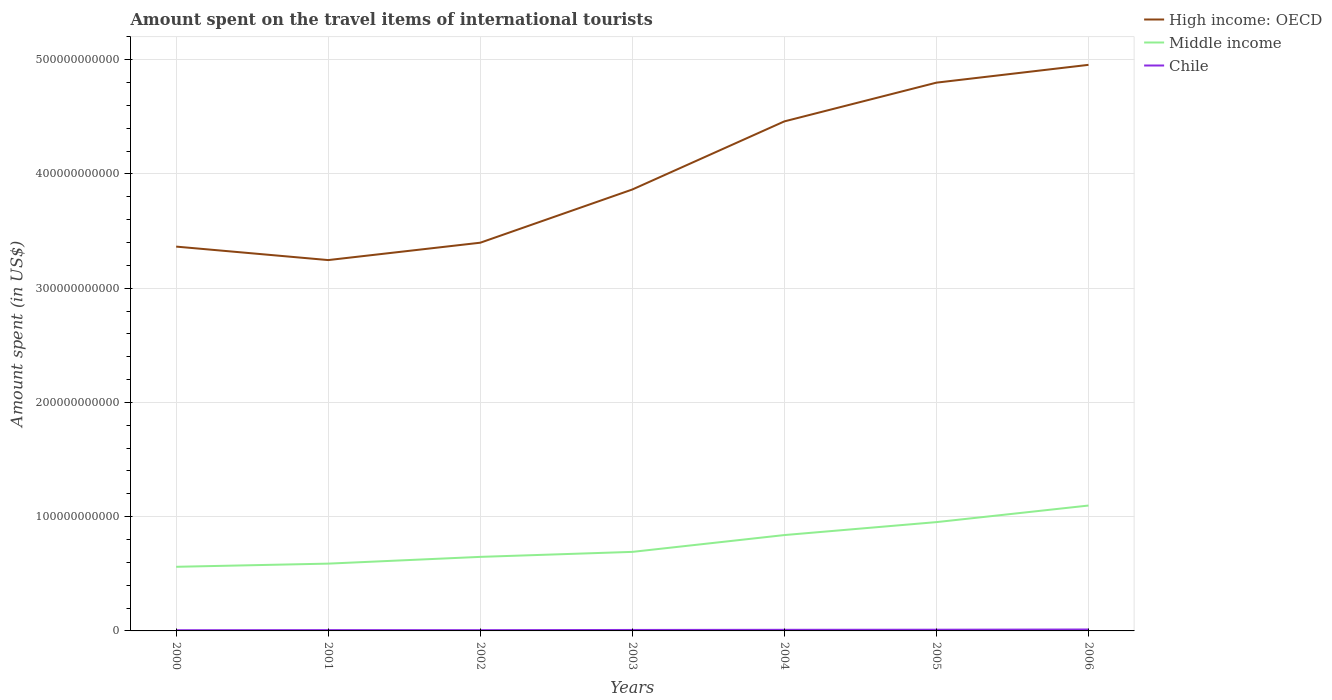Is the number of lines equal to the number of legend labels?
Ensure brevity in your answer.  Yes. Across all years, what is the maximum amount spent on the travel items of international tourists in Chile?
Ensure brevity in your answer.  6.20e+08. In which year was the amount spent on the travel items of international tourists in Middle income maximum?
Offer a very short reply. 2000. What is the total amount spent on the travel items of international tourists in Middle income in the graph?
Offer a terse response. -1.45e+1. What is the difference between the highest and the second highest amount spent on the travel items of international tourists in Middle income?
Your answer should be very brief. 5.36e+1. Is the amount spent on the travel items of international tourists in Chile strictly greater than the amount spent on the travel items of international tourists in Middle income over the years?
Offer a very short reply. Yes. What is the difference between two consecutive major ticks on the Y-axis?
Your answer should be very brief. 1.00e+11. Does the graph contain any zero values?
Offer a very short reply. No. How many legend labels are there?
Offer a very short reply. 3. How are the legend labels stacked?
Your answer should be very brief. Vertical. What is the title of the graph?
Your response must be concise. Amount spent on the travel items of international tourists. Does "Armenia" appear as one of the legend labels in the graph?
Your response must be concise. No. What is the label or title of the X-axis?
Offer a very short reply. Years. What is the label or title of the Y-axis?
Keep it short and to the point. Amount spent (in US$). What is the Amount spent (in US$) in High income: OECD in 2000?
Ensure brevity in your answer.  3.36e+11. What is the Amount spent (in US$) in Middle income in 2000?
Your answer should be very brief. 5.61e+1. What is the Amount spent (in US$) of Chile in 2000?
Offer a terse response. 6.20e+08. What is the Amount spent (in US$) of High income: OECD in 2001?
Your answer should be compact. 3.25e+11. What is the Amount spent (in US$) in Middle income in 2001?
Your answer should be compact. 5.89e+1. What is the Amount spent (in US$) in Chile in 2001?
Make the answer very short. 7.08e+08. What is the Amount spent (in US$) in High income: OECD in 2002?
Offer a very short reply. 3.40e+11. What is the Amount spent (in US$) of Middle income in 2002?
Offer a terse response. 6.48e+1. What is the Amount spent (in US$) of Chile in 2002?
Offer a terse response. 6.73e+08. What is the Amount spent (in US$) in High income: OECD in 2003?
Your answer should be compact. 3.86e+11. What is the Amount spent (in US$) of Middle income in 2003?
Ensure brevity in your answer.  6.92e+1. What is the Amount spent (in US$) of Chile in 2003?
Ensure brevity in your answer.  8.50e+08. What is the Amount spent (in US$) in High income: OECD in 2004?
Provide a succinct answer. 4.46e+11. What is the Amount spent (in US$) in Middle income in 2004?
Your answer should be compact. 8.39e+1. What is the Amount spent (in US$) in Chile in 2004?
Make the answer very short. 9.77e+08. What is the Amount spent (in US$) in High income: OECD in 2005?
Give a very brief answer. 4.80e+11. What is the Amount spent (in US$) in Middle income in 2005?
Provide a succinct answer. 9.52e+1. What is the Amount spent (in US$) of Chile in 2005?
Your answer should be very brief. 1.05e+09. What is the Amount spent (in US$) in High income: OECD in 2006?
Your response must be concise. 4.95e+11. What is the Amount spent (in US$) in Middle income in 2006?
Your response must be concise. 1.10e+11. What is the Amount spent (in US$) of Chile in 2006?
Keep it short and to the point. 1.24e+09. Across all years, what is the maximum Amount spent (in US$) in High income: OECD?
Keep it short and to the point. 4.95e+11. Across all years, what is the maximum Amount spent (in US$) in Middle income?
Offer a terse response. 1.10e+11. Across all years, what is the maximum Amount spent (in US$) of Chile?
Provide a short and direct response. 1.24e+09. Across all years, what is the minimum Amount spent (in US$) in High income: OECD?
Your answer should be very brief. 3.25e+11. Across all years, what is the minimum Amount spent (in US$) of Middle income?
Keep it short and to the point. 5.61e+1. Across all years, what is the minimum Amount spent (in US$) in Chile?
Give a very brief answer. 6.20e+08. What is the total Amount spent (in US$) of High income: OECD in the graph?
Provide a succinct answer. 2.81e+12. What is the total Amount spent (in US$) of Middle income in the graph?
Offer a very short reply. 5.38e+11. What is the total Amount spent (in US$) of Chile in the graph?
Provide a short and direct response. 6.12e+09. What is the difference between the Amount spent (in US$) of High income: OECD in 2000 and that in 2001?
Your answer should be compact. 1.18e+1. What is the difference between the Amount spent (in US$) of Middle income in 2000 and that in 2001?
Ensure brevity in your answer.  -2.77e+09. What is the difference between the Amount spent (in US$) of Chile in 2000 and that in 2001?
Provide a succinct answer. -8.80e+07. What is the difference between the Amount spent (in US$) in High income: OECD in 2000 and that in 2002?
Offer a terse response. -3.41e+09. What is the difference between the Amount spent (in US$) in Middle income in 2000 and that in 2002?
Give a very brief answer. -8.68e+09. What is the difference between the Amount spent (in US$) of Chile in 2000 and that in 2002?
Your answer should be compact. -5.30e+07. What is the difference between the Amount spent (in US$) of High income: OECD in 2000 and that in 2003?
Keep it short and to the point. -5.00e+1. What is the difference between the Amount spent (in US$) of Middle income in 2000 and that in 2003?
Your response must be concise. -1.31e+1. What is the difference between the Amount spent (in US$) of Chile in 2000 and that in 2003?
Your answer should be very brief. -2.30e+08. What is the difference between the Amount spent (in US$) of High income: OECD in 2000 and that in 2004?
Give a very brief answer. -1.10e+11. What is the difference between the Amount spent (in US$) of Middle income in 2000 and that in 2004?
Make the answer very short. -2.78e+1. What is the difference between the Amount spent (in US$) of Chile in 2000 and that in 2004?
Your answer should be compact. -3.57e+08. What is the difference between the Amount spent (in US$) in High income: OECD in 2000 and that in 2005?
Offer a terse response. -1.44e+11. What is the difference between the Amount spent (in US$) of Middle income in 2000 and that in 2005?
Keep it short and to the point. -3.91e+1. What is the difference between the Amount spent (in US$) of Chile in 2000 and that in 2005?
Offer a terse response. -4.31e+08. What is the difference between the Amount spent (in US$) in High income: OECD in 2000 and that in 2006?
Your response must be concise. -1.59e+11. What is the difference between the Amount spent (in US$) in Middle income in 2000 and that in 2006?
Your response must be concise. -5.36e+1. What is the difference between the Amount spent (in US$) in Chile in 2000 and that in 2006?
Offer a terse response. -6.19e+08. What is the difference between the Amount spent (in US$) in High income: OECD in 2001 and that in 2002?
Offer a terse response. -1.52e+1. What is the difference between the Amount spent (in US$) in Middle income in 2001 and that in 2002?
Provide a short and direct response. -5.91e+09. What is the difference between the Amount spent (in US$) of Chile in 2001 and that in 2002?
Your answer should be compact. 3.50e+07. What is the difference between the Amount spent (in US$) in High income: OECD in 2001 and that in 2003?
Offer a very short reply. -6.18e+1. What is the difference between the Amount spent (in US$) in Middle income in 2001 and that in 2003?
Your answer should be very brief. -1.03e+1. What is the difference between the Amount spent (in US$) in Chile in 2001 and that in 2003?
Offer a very short reply. -1.42e+08. What is the difference between the Amount spent (in US$) in High income: OECD in 2001 and that in 2004?
Offer a terse response. -1.21e+11. What is the difference between the Amount spent (in US$) of Middle income in 2001 and that in 2004?
Ensure brevity in your answer.  -2.50e+1. What is the difference between the Amount spent (in US$) of Chile in 2001 and that in 2004?
Keep it short and to the point. -2.69e+08. What is the difference between the Amount spent (in US$) in High income: OECD in 2001 and that in 2005?
Your response must be concise. -1.55e+11. What is the difference between the Amount spent (in US$) of Middle income in 2001 and that in 2005?
Your answer should be very brief. -3.63e+1. What is the difference between the Amount spent (in US$) in Chile in 2001 and that in 2005?
Offer a terse response. -3.43e+08. What is the difference between the Amount spent (in US$) of High income: OECD in 2001 and that in 2006?
Your response must be concise. -1.71e+11. What is the difference between the Amount spent (in US$) in Middle income in 2001 and that in 2006?
Your answer should be very brief. -5.08e+1. What is the difference between the Amount spent (in US$) in Chile in 2001 and that in 2006?
Ensure brevity in your answer.  -5.31e+08. What is the difference between the Amount spent (in US$) in High income: OECD in 2002 and that in 2003?
Ensure brevity in your answer.  -4.66e+1. What is the difference between the Amount spent (in US$) of Middle income in 2002 and that in 2003?
Your answer should be very brief. -4.37e+09. What is the difference between the Amount spent (in US$) of Chile in 2002 and that in 2003?
Provide a succinct answer. -1.77e+08. What is the difference between the Amount spent (in US$) in High income: OECD in 2002 and that in 2004?
Provide a succinct answer. -1.06e+11. What is the difference between the Amount spent (in US$) of Middle income in 2002 and that in 2004?
Make the answer very short. -1.91e+1. What is the difference between the Amount spent (in US$) in Chile in 2002 and that in 2004?
Provide a succinct answer. -3.04e+08. What is the difference between the Amount spent (in US$) of High income: OECD in 2002 and that in 2005?
Offer a terse response. -1.40e+11. What is the difference between the Amount spent (in US$) of Middle income in 2002 and that in 2005?
Give a very brief answer. -3.04e+1. What is the difference between the Amount spent (in US$) of Chile in 2002 and that in 2005?
Ensure brevity in your answer.  -3.78e+08. What is the difference between the Amount spent (in US$) in High income: OECD in 2002 and that in 2006?
Your response must be concise. -1.56e+11. What is the difference between the Amount spent (in US$) of Middle income in 2002 and that in 2006?
Your answer should be very brief. -4.49e+1. What is the difference between the Amount spent (in US$) of Chile in 2002 and that in 2006?
Your response must be concise. -5.66e+08. What is the difference between the Amount spent (in US$) in High income: OECD in 2003 and that in 2004?
Keep it short and to the point. -5.96e+1. What is the difference between the Amount spent (in US$) in Middle income in 2003 and that in 2004?
Give a very brief answer. -1.47e+1. What is the difference between the Amount spent (in US$) of Chile in 2003 and that in 2004?
Your response must be concise. -1.27e+08. What is the difference between the Amount spent (in US$) in High income: OECD in 2003 and that in 2005?
Keep it short and to the point. -9.35e+1. What is the difference between the Amount spent (in US$) in Middle income in 2003 and that in 2005?
Offer a very short reply. -2.61e+1. What is the difference between the Amount spent (in US$) in Chile in 2003 and that in 2005?
Provide a succinct answer. -2.01e+08. What is the difference between the Amount spent (in US$) in High income: OECD in 2003 and that in 2006?
Your answer should be very brief. -1.09e+11. What is the difference between the Amount spent (in US$) of Middle income in 2003 and that in 2006?
Give a very brief answer. -4.06e+1. What is the difference between the Amount spent (in US$) in Chile in 2003 and that in 2006?
Keep it short and to the point. -3.89e+08. What is the difference between the Amount spent (in US$) of High income: OECD in 2004 and that in 2005?
Your answer should be very brief. -3.39e+1. What is the difference between the Amount spent (in US$) of Middle income in 2004 and that in 2005?
Ensure brevity in your answer.  -1.13e+1. What is the difference between the Amount spent (in US$) of Chile in 2004 and that in 2005?
Keep it short and to the point. -7.40e+07. What is the difference between the Amount spent (in US$) in High income: OECD in 2004 and that in 2006?
Give a very brief answer. -4.95e+1. What is the difference between the Amount spent (in US$) in Middle income in 2004 and that in 2006?
Your response must be concise. -2.58e+1. What is the difference between the Amount spent (in US$) in Chile in 2004 and that in 2006?
Keep it short and to the point. -2.62e+08. What is the difference between the Amount spent (in US$) of High income: OECD in 2005 and that in 2006?
Provide a short and direct response. -1.56e+1. What is the difference between the Amount spent (in US$) in Middle income in 2005 and that in 2006?
Your answer should be compact. -1.45e+1. What is the difference between the Amount spent (in US$) in Chile in 2005 and that in 2006?
Provide a succinct answer. -1.88e+08. What is the difference between the Amount spent (in US$) of High income: OECD in 2000 and the Amount spent (in US$) of Middle income in 2001?
Offer a very short reply. 2.77e+11. What is the difference between the Amount spent (in US$) in High income: OECD in 2000 and the Amount spent (in US$) in Chile in 2001?
Keep it short and to the point. 3.36e+11. What is the difference between the Amount spent (in US$) in Middle income in 2000 and the Amount spent (in US$) in Chile in 2001?
Make the answer very short. 5.54e+1. What is the difference between the Amount spent (in US$) in High income: OECD in 2000 and the Amount spent (in US$) in Middle income in 2002?
Your answer should be compact. 2.72e+11. What is the difference between the Amount spent (in US$) of High income: OECD in 2000 and the Amount spent (in US$) of Chile in 2002?
Offer a terse response. 3.36e+11. What is the difference between the Amount spent (in US$) in Middle income in 2000 and the Amount spent (in US$) in Chile in 2002?
Give a very brief answer. 5.55e+1. What is the difference between the Amount spent (in US$) of High income: OECD in 2000 and the Amount spent (in US$) of Middle income in 2003?
Your response must be concise. 2.67e+11. What is the difference between the Amount spent (in US$) of High income: OECD in 2000 and the Amount spent (in US$) of Chile in 2003?
Your response must be concise. 3.36e+11. What is the difference between the Amount spent (in US$) of Middle income in 2000 and the Amount spent (in US$) of Chile in 2003?
Make the answer very short. 5.53e+1. What is the difference between the Amount spent (in US$) in High income: OECD in 2000 and the Amount spent (in US$) in Middle income in 2004?
Provide a succinct answer. 2.52e+11. What is the difference between the Amount spent (in US$) of High income: OECD in 2000 and the Amount spent (in US$) of Chile in 2004?
Make the answer very short. 3.35e+11. What is the difference between the Amount spent (in US$) in Middle income in 2000 and the Amount spent (in US$) in Chile in 2004?
Keep it short and to the point. 5.52e+1. What is the difference between the Amount spent (in US$) in High income: OECD in 2000 and the Amount spent (in US$) in Middle income in 2005?
Your answer should be compact. 2.41e+11. What is the difference between the Amount spent (in US$) of High income: OECD in 2000 and the Amount spent (in US$) of Chile in 2005?
Your answer should be very brief. 3.35e+11. What is the difference between the Amount spent (in US$) in Middle income in 2000 and the Amount spent (in US$) in Chile in 2005?
Your answer should be very brief. 5.51e+1. What is the difference between the Amount spent (in US$) in High income: OECD in 2000 and the Amount spent (in US$) in Middle income in 2006?
Keep it short and to the point. 2.27e+11. What is the difference between the Amount spent (in US$) of High income: OECD in 2000 and the Amount spent (in US$) of Chile in 2006?
Offer a very short reply. 3.35e+11. What is the difference between the Amount spent (in US$) in Middle income in 2000 and the Amount spent (in US$) in Chile in 2006?
Give a very brief answer. 5.49e+1. What is the difference between the Amount spent (in US$) of High income: OECD in 2001 and the Amount spent (in US$) of Middle income in 2002?
Provide a succinct answer. 2.60e+11. What is the difference between the Amount spent (in US$) in High income: OECD in 2001 and the Amount spent (in US$) in Chile in 2002?
Make the answer very short. 3.24e+11. What is the difference between the Amount spent (in US$) in Middle income in 2001 and the Amount spent (in US$) in Chile in 2002?
Make the answer very short. 5.82e+1. What is the difference between the Amount spent (in US$) in High income: OECD in 2001 and the Amount spent (in US$) in Middle income in 2003?
Keep it short and to the point. 2.55e+11. What is the difference between the Amount spent (in US$) of High income: OECD in 2001 and the Amount spent (in US$) of Chile in 2003?
Ensure brevity in your answer.  3.24e+11. What is the difference between the Amount spent (in US$) in Middle income in 2001 and the Amount spent (in US$) in Chile in 2003?
Offer a terse response. 5.80e+1. What is the difference between the Amount spent (in US$) in High income: OECD in 2001 and the Amount spent (in US$) in Middle income in 2004?
Offer a terse response. 2.41e+11. What is the difference between the Amount spent (in US$) in High income: OECD in 2001 and the Amount spent (in US$) in Chile in 2004?
Keep it short and to the point. 3.24e+11. What is the difference between the Amount spent (in US$) of Middle income in 2001 and the Amount spent (in US$) of Chile in 2004?
Provide a succinct answer. 5.79e+1. What is the difference between the Amount spent (in US$) in High income: OECD in 2001 and the Amount spent (in US$) in Middle income in 2005?
Ensure brevity in your answer.  2.29e+11. What is the difference between the Amount spent (in US$) of High income: OECD in 2001 and the Amount spent (in US$) of Chile in 2005?
Ensure brevity in your answer.  3.24e+11. What is the difference between the Amount spent (in US$) of Middle income in 2001 and the Amount spent (in US$) of Chile in 2005?
Your answer should be compact. 5.78e+1. What is the difference between the Amount spent (in US$) of High income: OECD in 2001 and the Amount spent (in US$) of Middle income in 2006?
Your answer should be compact. 2.15e+11. What is the difference between the Amount spent (in US$) in High income: OECD in 2001 and the Amount spent (in US$) in Chile in 2006?
Your response must be concise. 3.23e+11. What is the difference between the Amount spent (in US$) in Middle income in 2001 and the Amount spent (in US$) in Chile in 2006?
Give a very brief answer. 5.77e+1. What is the difference between the Amount spent (in US$) in High income: OECD in 2002 and the Amount spent (in US$) in Middle income in 2003?
Your answer should be compact. 2.71e+11. What is the difference between the Amount spent (in US$) of High income: OECD in 2002 and the Amount spent (in US$) of Chile in 2003?
Your response must be concise. 3.39e+11. What is the difference between the Amount spent (in US$) in Middle income in 2002 and the Amount spent (in US$) in Chile in 2003?
Your answer should be very brief. 6.40e+1. What is the difference between the Amount spent (in US$) of High income: OECD in 2002 and the Amount spent (in US$) of Middle income in 2004?
Give a very brief answer. 2.56e+11. What is the difference between the Amount spent (in US$) in High income: OECD in 2002 and the Amount spent (in US$) in Chile in 2004?
Offer a very short reply. 3.39e+11. What is the difference between the Amount spent (in US$) of Middle income in 2002 and the Amount spent (in US$) of Chile in 2004?
Provide a succinct answer. 6.38e+1. What is the difference between the Amount spent (in US$) in High income: OECD in 2002 and the Amount spent (in US$) in Middle income in 2005?
Provide a succinct answer. 2.45e+11. What is the difference between the Amount spent (in US$) of High income: OECD in 2002 and the Amount spent (in US$) of Chile in 2005?
Keep it short and to the point. 3.39e+11. What is the difference between the Amount spent (in US$) of Middle income in 2002 and the Amount spent (in US$) of Chile in 2005?
Offer a very short reply. 6.38e+1. What is the difference between the Amount spent (in US$) of High income: OECD in 2002 and the Amount spent (in US$) of Middle income in 2006?
Your answer should be compact. 2.30e+11. What is the difference between the Amount spent (in US$) of High income: OECD in 2002 and the Amount spent (in US$) of Chile in 2006?
Provide a succinct answer. 3.39e+11. What is the difference between the Amount spent (in US$) in Middle income in 2002 and the Amount spent (in US$) in Chile in 2006?
Your response must be concise. 6.36e+1. What is the difference between the Amount spent (in US$) in High income: OECD in 2003 and the Amount spent (in US$) in Middle income in 2004?
Ensure brevity in your answer.  3.02e+11. What is the difference between the Amount spent (in US$) in High income: OECD in 2003 and the Amount spent (in US$) in Chile in 2004?
Give a very brief answer. 3.85e+11. What is the difference between the Amount spent (in US$) in Middle income in 2003 and the Amount spent (in US$) in Chile in 2004?
Your answer should be very brief. 6.82e+1. What is the difference between the Amount spent (in US$) in High income: OECD in 2003 and the Amount spent (in US$) in Middle income in 2005?
Provide a short and direct response. 2.91e+11. What is the difference between the Amount spent (in US$) in High income: OECD in 2003 and the Amount spent (in US$) in Chile in 2005?
Your answer should be compact. 3.85e+11. What is the difference between the Amount spent (in US$) of Middle income in 2003 and the Amount spent (in US$) of Chile in 2005?
Your response must be concise. 6.81e+1. What is the difference between the Amount spent (in US$) of High income: OECD in 2003 and the Amount spent (in US$) of Middle income in 2006?
Provide a short and direct response. 2.77e+11. What is the difference between the Amount spent (in US$) of High income: OECD in 2003 and the Amount spent (in US$) of Chile in 2006?
Provide a succinct answer. 3.85e+11. What is the difference between the Amount spent (in US$) of Middle income in 2003 and the Amount spent (in US$) of Chile in 2006?
Your answer should be compact. 6.79e+1. What is the difference between the Amount spent (in US$) of High income: OECD in 2004 and the Amount spent (in US$) of Middle income in 2005?
Provide a succinct answer. 3.51e+11. What is the difference between the Amount spent (in US$) of High income: OECD in 2004 and the Amount spent (in US$) of Chile in 2005?
Give a very brief answer. 4.45e+11. What is the difference between the Amount spent (in US$) in Middle income in 2004 and the Amount spent (in US$) in Chile in 2005?
Make the answer very short. 8.28e+1. What is the difference between the Amount spent (in US$) in High income: OECD in 2004 and the Amount spent (in US$) in Middle income in 2006?
Provide a succinct answer. 3.36e+11. What is the difference between the Amount spent (in US$) in High income: OECD in 2004 and the Amount spent (in US$) in Chile in 2006?
Ensure brevity in your answer.  4.45e+11. What is the difference between the Amount spent (in US$) in Middle income in 2004 and the Amount spent (in US$) in Chile in 2006?
Give a very brief answer. 8.27e+1. What is the difference between the Amount spent (in US$) of High income: OECD in 2005 and the Amount spent (in US$) of Middle income in 2006?
Your answer should be compact. 3.70e+11. What is the difference between the Amount spent (in US$) of High income: OECD in 2005 and the Amount spent (in US$) of Chile in 2006?
Provide a succinct answer. 4.79e+11. What is the difference between the Amount spent (in US$) of Middle income in 2005 and the Amount spent (in US$) of Chile in 2006?
Keep it short and to the point. 9.40e+1. What is the average Amount spent (in US$) in High income: OECD per year?
Offer a very short reply. 4.01e+11. What is the average Amount spent (in US$) in Middle income per year?
Your answer should be very brief. 7.68e+1. What is the average Amount spent (in US$) of Chile per year?
Your answer should be compact. 8.74e+08. In the year 2000, what is the difference between the Amount spent (in US$) in High income: OECD and Amount spent (in US$) in Middle income?
Your answer should be compact. 2.80e+11. In the year 2000, what is the difference between the Amount spent (in US$) of High income: OECD and Amount spent (in US$) of Chile?
Provide a short and direct response. 3.36e+11. In the year 2000, what is the difference between the Amount spent (in US$) in Middle income and Amount spent (in US$) in Chile?
Offer a terse response. 5.55e+1. In the year 2001, what is the difference between the Amount spent (in US$) in High income: OECD and Amount spent (in US$) in Middle income?
Provide a succinct answer. 2.66e+11. In the year 2001, what is the difference between the Amount spent (in US$) of High income: OECD and Amount spent (in US$) of Chile?
Ensure brevity in your answer.  3.24e+11. In the year 2001, what is the difference between the Amount spent (in US$) of Middle income and Amount spent (in US$) of Chile?
Your response must be concise. 5.82e+1. In the year 2002, what is the difference between the Amount spent (in US$) of High income: OECD and Amount spent (in US$) of Middle income?
Your answer should be compact. 2.75e+11. In the year 2002, what is the difference between the Amount spent (in US$) in High income: OECD and Amount spent (in US$) in Chile?
Offer a terse response. 3.39e+11. In the year 2002, what is the difference between the Amount spent (in US$) in Middle income and Amount spent (in US$) in Chile?
Make the answer very short. 6.41e+1. In the year 2003, what is the difference between the Amount spent (in US$) in High income: OECD and Amount spent (in US$) in Middle income?
Your response must be concise. 3.17e+11. In the year 2003, what is the difference between the Amount spent (in US$) of High income: OECD and Amount spent (in US$) of Chile?
Ensure brevity in your answer.  3.86e+11. In the year 2003, what is the difference between the Amount spent (in US$) in Middle income and Amount spent (in US$) in Chile?
Offer a very short reply. 6.83e+1. In the year 2004, what is the difference between the Amount spent (in US$) of High income: OECD and Amount spent (in US$) of Middle income?
Provide a succinct answer. 3.62e+11. In the year 2004, what is the difference between the Amount spent (in US$) in High income: OECD and Amount spent (in US$) in Chile?
Provide a succinct answer. 4.45e+11. In the year 2004, what is the difference between the Amount spent (in US$) of Middle income and Amount spent (in US$) of Chile?
Your answer should be very brief. 8.29e+1. In the year 2005, what is the difference between the Amount spent (in US$) of High income: OECD and Amount spent (in US$) of Middle income?
Your answer should be very brief. 3.85e+11. In the year 2005, what is the difference between the Amount spent (in US$) in High income: OECD and Amount spent (in US$) in Chile?
Your response must be concise. 4.79e+11. In the year 2005, what is the difference between the Amount spent (in US$) in Middle income and Amount spent (in US$) in Chile?
Make the answer very short. 9.42e+1. In the year 2006, what is the difference between the Amount spent (in US$) in High income: OECD and Amount spent (in US$) in Middle income?
Make the answer very short. 3.86e+11. In the year 2006, what is the difference between the Amount spent (in US$) in High income: OECD and Amount spent (in US$) in Chile?
Your answer should be very brief. 4.94e+11. In the year 2006, what is the difference between the Amount spent (in US$) in Middle income and Amount spent (in US$) in Chile?
Ensure brevity in your answer.  1.08e+11. What is the ratio of the Amount spent (in US$) in High income: OECD in 2000 to that in 2001?
Your answer should be compact. 1.04. What is the ratio of the Amount spent (in US$) in Middle income in 2000 to that in 2001?
Offer a terse response. 0.95. What is the ratio of the Amount spent (in US$) of Chile in 2000 to that in 2001?
Your response must be concise. 0.88. What is the ratio of the Amount spent (in US$) of Middle income in 2000 to that in 2002?
Offer a very short reply. 0.87. What is the ratio of the Amount spent (in US$) of Chile in 2000 to that in 2002?
Provide a short and direct response. 0.92. What is the ratio of the Amount spent (in US$) in High income: OECD in 2000 to that in 2003?
Your answer should be very brief. 0.87. What is the ratio of the Amount spent (in US$) in Middle income in 2000 to that in 2003?
Offer a very short reply. 0.81. What is the ratio of the Amount spent (in US$) in Chile in 2000 to that in 2003?
Ensure brevity in your answer.  0.73. What is the ratio of the Amount spent (in US$) of High income: OECD in 2000 to that in 2004?
Your response must be concise. 0.75. What is the ratio of the Amount spent (in US$) of Middle income in 2000 to that in 2004?
Your answer should be very brief. 0.67. What is the ratio of the Amount spent (in US$) of Chile in 2000 to that in 2004?
Ensure brevity in your answer.  0.63. What is the ratio of the Amount spent (in US$) in High income: OECD in 2000 to that in 2005?
Provide a short and direct response. 0.7. What is the ratio of the Amount spent (in US$) of Middle income in 2000 to that in 2005?
Give a very brief answer. 0.59. What is the ratio of the Amount spent (in US$) of Chile in 2000 to that in 2005?
Provide a short and direct response. 0.59. What is the ratio of the Amount spent (in US$) in High income: OECD in 2000 to that in 2006?
Offer a terse response. 0.68. What is the ratio of the Amount spent (in US$) in Middle income in 2000 to that in 2006?
Offer a terse response. 0.51. What is the ratio of the Amount spent (in US$) in Chile in 2000 to that in 2006?
Offer a terse response. 0.5. What is the ratio of the Amount spent (in US$) of High income: OECD in 2001 to that in 2002?
Ensure brevity in your answer.  0.96. What is the ratio of the Amount spent (in US$) in Middle income in 2001 to that in 2002?
Offer a very short reply. 0.91. What is the ratio of the Amount spent (in US$) of Chile in 2001 to that in 2002?
Offer a terse response. 1.05. What is the ratio of the Amount spent (in US$) in High income: OECD in 2001 to that in 2003?
Your response must be concise. 0.84. What is the ratio of the Amount spent (in US$) of Middle income in 2001 to that in 2003?
Your answer should be very brief. 0.85. What is the ratio of the Amount spent (in US$) of Chile in 2001 to that in 2003?
Your response must be concise. 0.83. What is the ratio of the Amount spent (in US$) of High income: OECD in 2001 to that in 2004?
Offer a terse response. 0.73. What is the ratio of the Amount spent (in US$) of Middle income in 2001 to that in 2004?
Give a very brief answer. 0.7. What is the ratio of the Amount spent (in US$) in Chile in 2001 to that in 2004?
Your answer should be very brief. 0.72. What is the ratio of the Amount spent (in US$) in High income: OECD in 2001 to that in 2005?
Give a very brief answer. 0.68. What is the ratio of the Amount spent (in US$) in Middle income in 2001 to that in 2005?
Keep it short and to the point. 0.62. What is the ratio of the Amount spent (in US$) in Chile in 2001 to that in 2005?
Offer a terse response. 0.67. What is the ratio of the Amount spent (in US$) in High income: OECD in 2001 to that in 2006?
Offer a terse response. 0.66. What is the ratio of the Amount spent (in US$) in Middle income in 2001 to that in 2006?
Offer a terse response. 0.54. What is the ratio of the Amount spent (in US$) of Chile in 2001 to that in 2006?
Give a very brief answer. 0.57. What is the ratio of the Amount spent (in US$) of High income: OECD in 2002 to that in 2003?
Provide a succinct answer. 0.88. What is the ratio of the Amount spent (in US$) in Middle income in 2002 to that in 2003?
Offer a very short reply. 0.94. What is the ratio of the Amount spent (in US$) of Chile in 2002 to that in 2003?
Ensure brevity in your answer.  0.79. What is the ratio of the Amount spent (in US$) of High income: OECD in 2002 to that in 2004?
Your answer should be compact. 0.76. What is the ratio of the Amount spent (in US$) of Middle income in 2002 to that in 2004?
Provide a short and direct response. 0.77. What is the ratio of the Amount spent (in US$) of Chile in 2002 to that in 2004?
Offer a very short reply. 0.69. What is the ratio of the Amount spent (in US$) in High income: OECD in 2002 to that in 2005?
Provide a short and direct response. 0.71. What is the ratio of the Amount spent (in US$) of Middle income in 2002 to that in 2005?
Offer a very short reply. 0.68. What is the ratio of the Amount spent (in US$) of Chile in 2002 to that in 2005?
Provide a short and direct response. 0.64. What is the ratio of the Amount spent (in US$) in High income: OECD in 2002 to that in 2006?
Your response must be concise. 0.69. What is the ratio of the Amount spent (in US$) of Middle income in 2002 to that in 2006?
Your response must be concise. 0.59. What is the ratio of the Amount spent (in US$) in Chile in 2002 to that in 2006?
Keep it short and to the point. 0.54. What is the ratio of the Amount spent (in US$) of High income: OECD in 2003 to that in 2004?
Offer a terse response. 0.87. What is the ratio of the Amount spent (in US$) in Middle income in 2003 to that in 2004?
Make the answer very short. 0.82. What is the ratio of the Amount spent (in US$) of Chile in 2003 to that in 2004?
Ensure brevity in your answer.  0.87. What is the ratio of the Amount spent (in US$) of High income: OECD in 2003 to that in 2005?
Provide a short and direct response. 0.81. What is the ratio of the Amount spent (in US$) of Middle income in 2003 to that in 2005?
Ensure brevity in your answer.  0.73. What is the ratio of the Amount spent (in US$) in Chile in 2003 to that in 2005?
Your answer should be very brief. 0.81. What is the ratio of the Amount spent (in US$) in High income: OECD in 2003 to that in 2006?
Keep it short and to the point. 0.78. What is the ratio of the Amount spent (in US$) in Middle income in 2003 to that in 2006?
Make the answer very short. 0.63. What is the ratio of the Amount spent (in US$) in Chile in 2003 to that in 2006?
Keep it short and to the point. 0.69. What is the ratio of the Amount spent (in US$) of High income: OECD in 2004 to that in 2005?
Your response must be concise. 0.93. What is the ratio of the Amount spent (in US$) in Middle income in 2004 to that in 2005?
Your response must be concise. 0.88. What is the ratio of the Amount spent (in US$) in Chile in 2004 to that in 2005?
Give a very brief answer. 0.93. What is the ratio of the Amount spent (in US$) of High income: OECD in 2004 to that in 2006?
Offer a terse response. 0.9. What is the ratio of the Amount spent (in US$) of Middle income in 2004 to that in 2006?
Keep it short and to the point. 0.76. What is the ratio of the Amount spent (in US$) of Chile in 2004 to that in 2006?
Make the answer very short. 0.79. What is the ratio of the Amount spent (in US$) in High income: OECD in 2005 to that in 2006?
Ensure brevity in your answer.  0.97. What is the ratio of the Amount spent (in US$) in Middle income in 2005 to that in 2006?
Give a very brief answer. 0.87. What is the ratio of the Amount spent (in US$) of Chile in 2005 to that in 2006?
Offer a very short reply. 0.85. What is the difference between the highest and the second highest Amount spent (in US$) of High income: OECD?
Ensure brevity in your answer.  1.56e+1. What is the difference between the highest and the second highest Amount spent (in US$) in Middle income?
Offer a terse response. 1.45e+1. What is the difference between the highest and the second highest Amount spent (in US$) of Chile?
Ensure brevity in your answer.  1.88e+08. What is the difference between the highest and the lowest Amount spent (in US$) in High income: OECD?
Make the answer very short. 1.71e+11. What is the difference between the highest and the lowest Amount spent (in US$) in Middle income?
Make the answer very short. 5.36e+1. What is the difference between the highest and the lowest Amount spent (in US$) in Chile?
Your response must be concise. 6.19e+08. 